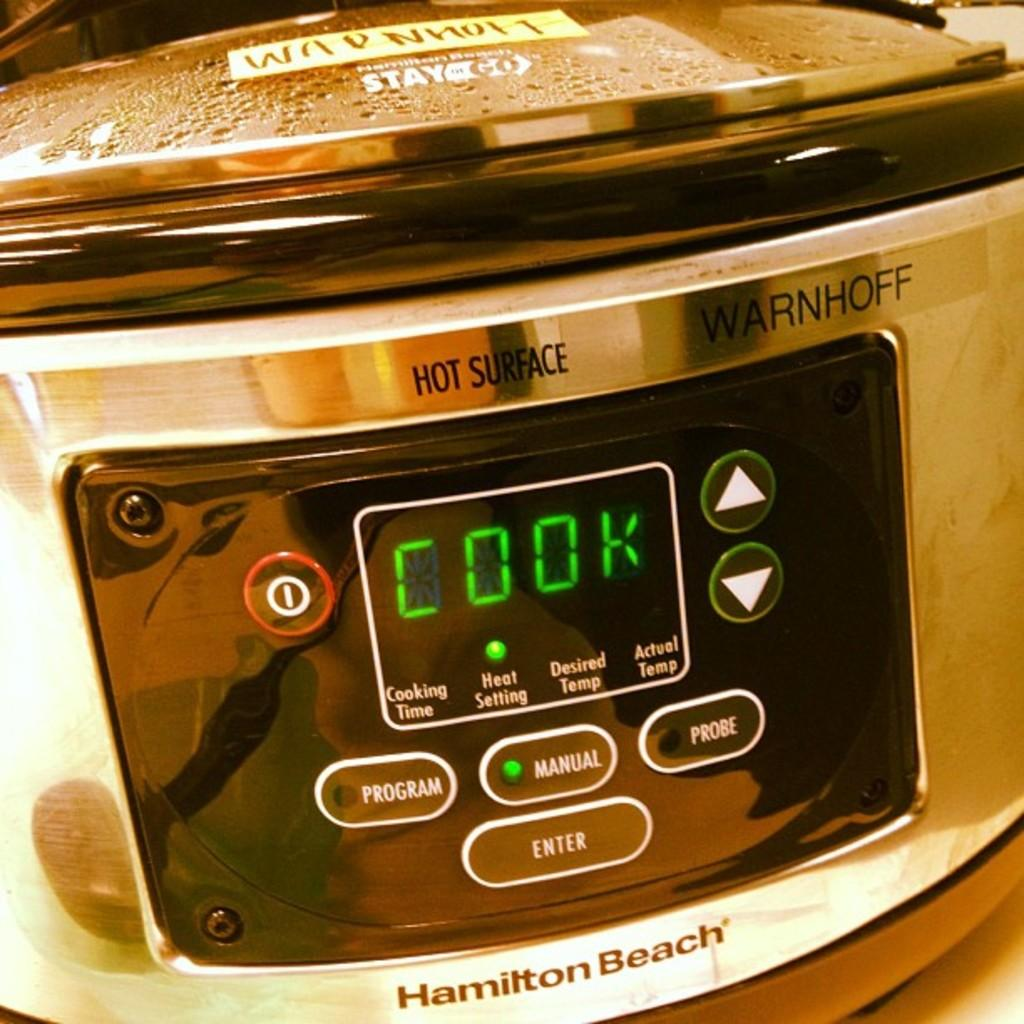<image>
Offer a succinct explanation of the picture presented. An appliance by Hamilton Beach says cook on the screen. 